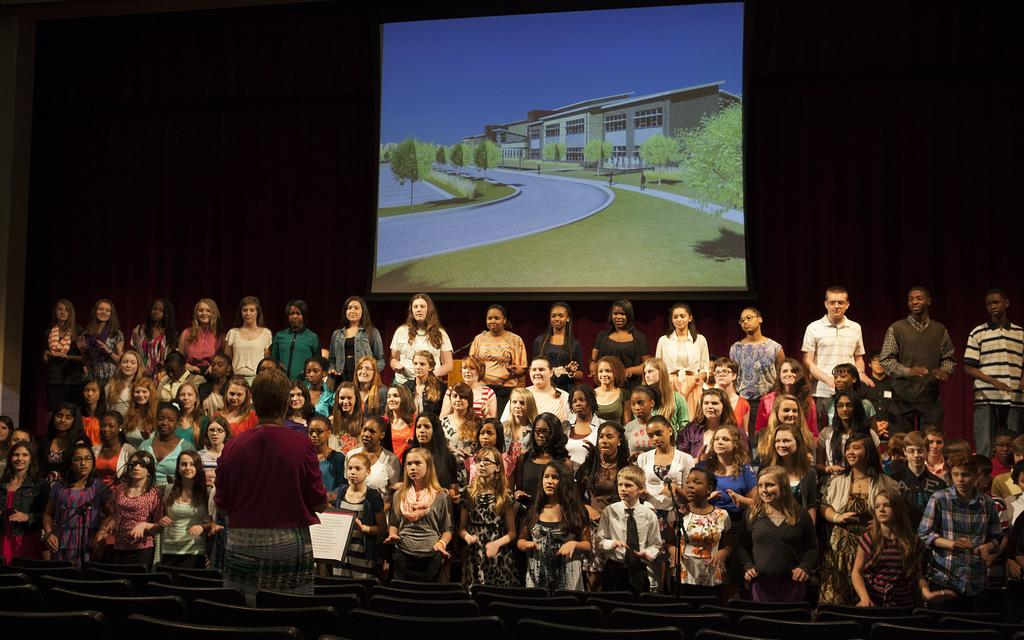Who is the main subject on the left side of the image? There is a woman standing on the left side of the image. What is the woman wearing in the image? The woman is wearing a dark red sweater. What else can be seen in the image besides the woman? There is a group of girls and boys, as well as a projected image in the middle of the image. How many dogs are present in the image? There are no dogs present in the image. What time is displayed on the clock in the image? There is no clock present in the image. 